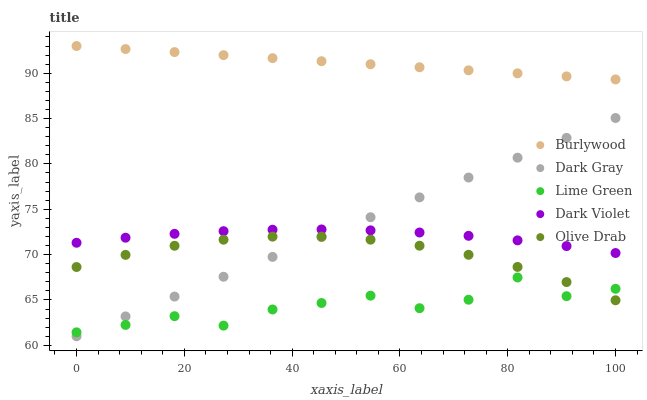Does Lime Green have the minimum area under the curve?
Answer yes or no. Yes. Does Burlywood have the maximum area under the curve?
Answer yes or no. Yes. Does Dark Gray have the minimum area under the curve?
Answer yes or no. No. Does Dark Gray have the maximum area under the curve?
Answer yes or no. No. Is Burlywood the smoothest?
Answer yes or no. Yes. Is Lime Green the roughest?
Answer yes or no. Yes. Is Dark Gray the smoothest?
Answer yes or no. No. Is Dark Gray the roughest?
Answer yes or no. No. Does Dark Gray have the lowest value?
Answer yes or no. Yes. Does Lime Green have the lowest value?
Answer yes or no. No. Does Burlywood have the highest value?
Answer yes or no. Yes. Does Dark Gray have the highest value?
Answer yes or no. No. Is Olive Drab less than Dark Violet?
Answer yes or no. Yes. Is Burlywood greater than Dark Gray?
Answer yes or no. Yes. Does Olive Drab intersect Dark Gray?
Answer yes or no. Yes. Is Olive Drab less than Dark Gray?
Answer yes or no. No. Is Olive Drab greater than Dark Gray?
Answer yes or no. No. Does Olive Drab intersect Dark Violet?
Answer yes or no. No. 